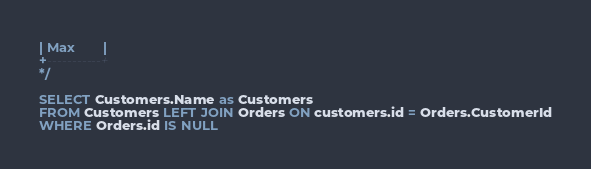Convert code to text. <code><loc_0><loc_0><loc_500><loc_500><_SQL_>| Max       |
+-----------+
*/

SELECT Customers.Name as Customers
FROM Customers LEFT JOIN Orders ON customers.id = Orders.CustomerId
WHERE Orders.id IS NULL 
</code> 